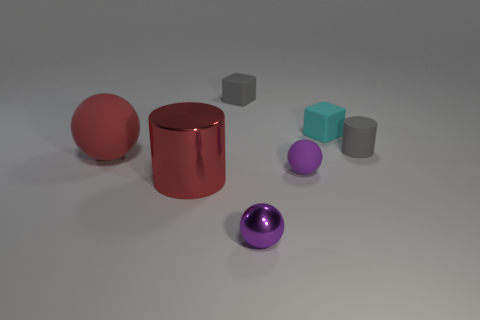There is a sphere that is the same size as the red cylinder; what color is it?
Make the answer very short. Red. What number of things are either tiny matte balls or balls?
Provide a succinct answer. 3. There is a gray matte cylinder; are there any red balls right of it?
Offer a very short reply. No. Are there any small gray blocks that have the same material as the red sphere?
Ensure brevity in your answer.  Yes. There is a metallic thing that is the same color as the large matte object; what is its size?
Ensure brevity in your answer.  Large. How many cylinders are either tiny things or matte objects?
Keep it short and to the point. 1. Is the number of objects that are behind the gray rubber cylinder greater than the number of cyan blocks on the left side of the large red metallic object?
Your response must be concise. Yes. What number of tiny rubber blocks are the same color as the tiny rubber cylinder?
Offer a terse response. 1. What size is the red sphere that is the same material as the tiny gray block?
Provide a succinct answer. Large. What number of objects are either cylinders that are behind the red shiny cylinder or large things?
Keep it short and to the point. 3. 